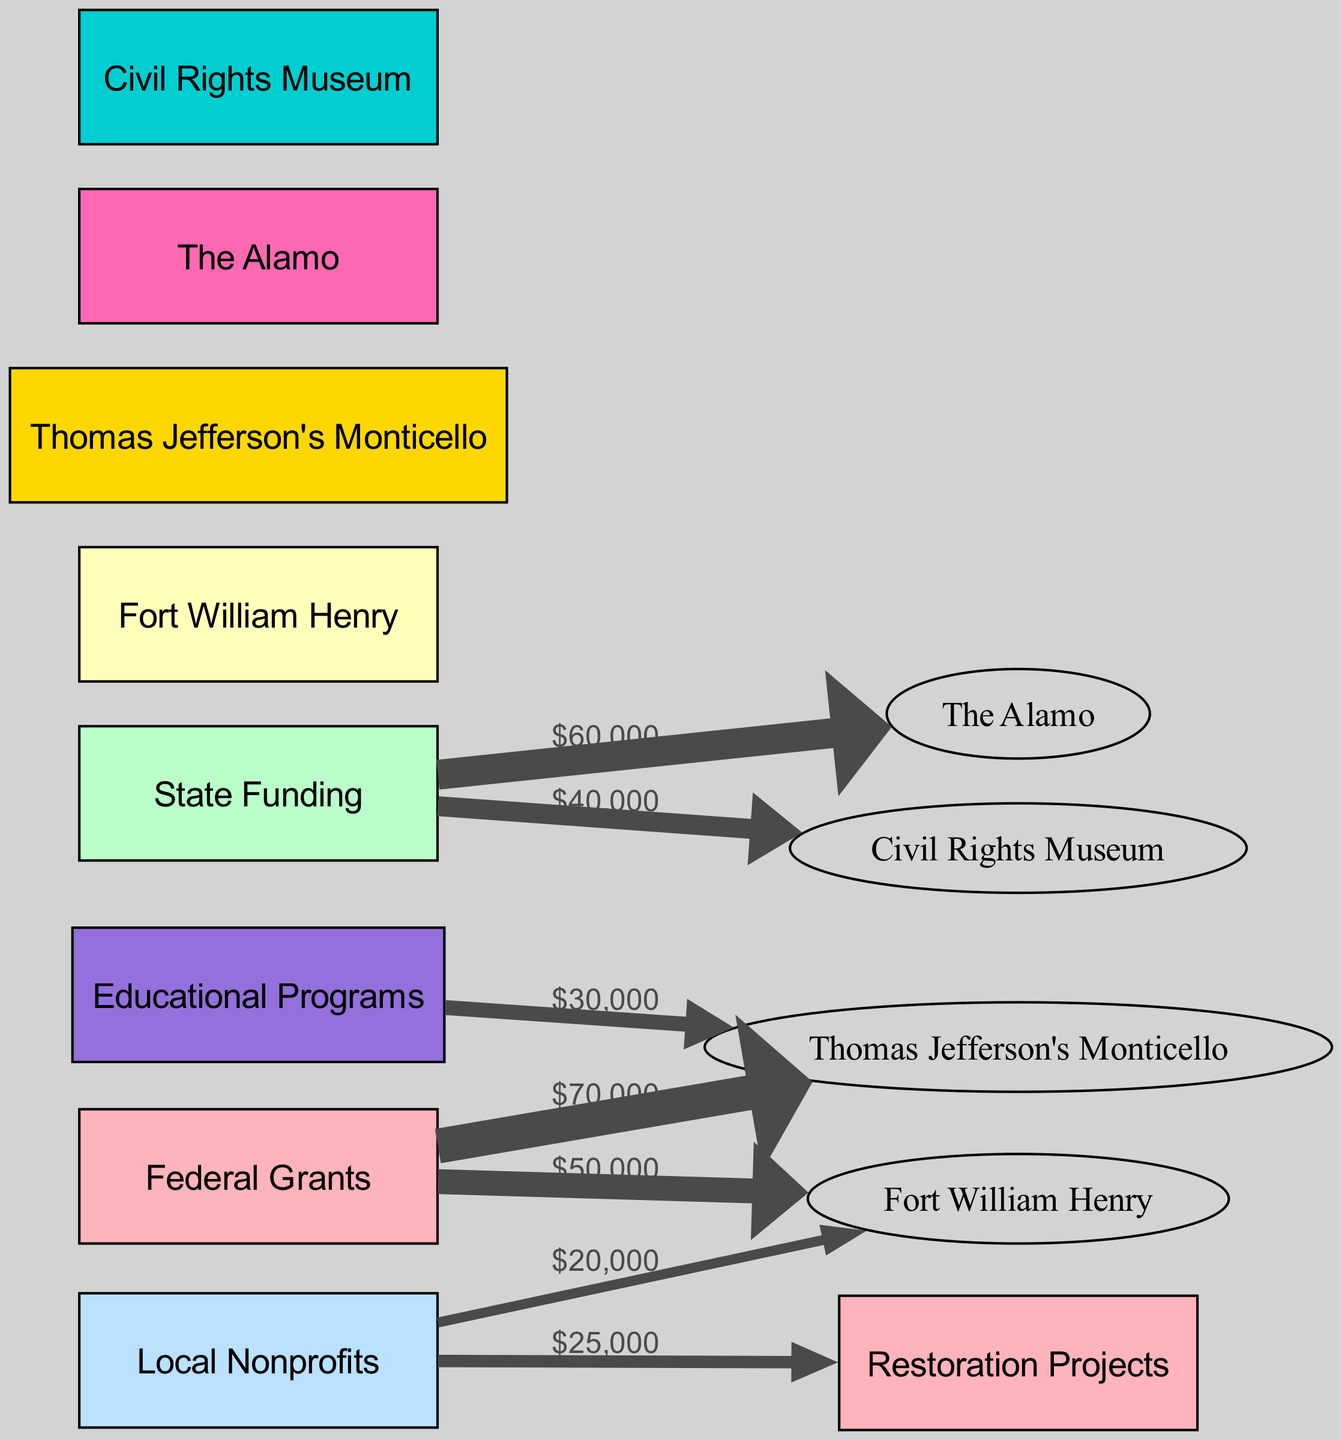What is the total funding allocated to Fort William Henry? To find the total funding for Fort William Henry, I will add the amounts from both Federal Grants and Local Nonprofits. Federal Grants provide $50,000 and Local Nonprofits provide $20,000. So, the total is $50,000 + $20,000 = $70,000.
Answer: $70,000 Which historical site received the highest funding from Federal Grants? The historical sites that received Federal Grants are Fort William Henry and Thomas Jefferson's Monticello, with grants of $50,000 and $70,000 respectively. The higher amount is $70,000 for Thomas Jefferson's Monticello.
Answer: Thomas Jefferson's Monticello What is the total amount of State Funding allocated to historical sites? The historical sites funded by State Funding are The Alamo and the Civil Rights Museum, which received $60,000 and $40,000, respectively. Adding these amounts gives $60,000 + $40,000 = $100,000 for State Funding.
Answer: $100,000 How much funding was allocated to Restoration Projects? From the diagram, the Restoration Projects received $25,000 from Local Nonprofits, and there are no other funding sources indicated for this category. Therefore, the total allocation is $25,000.
Answer: $25,000 Which source contributed the least amount of funding? The sources of funding are Federal Grants, State Funding, and Local Nonprofits. Reviewing the allocations: Federal Grants has $50,000 and $70,000, State Funding has $60,000 and $40,000, while Local Nonprofits has $20,000. The least is $20,000 from Local Nonprofits.
Answer: Local Nonprofits What is the combined funding for Thomas Jefferson's Monticello? Thomas Jefferson's Monticello received $70,000 from Federal Grants and $30,000 from Educational Programs. Adding these two amounts gives $70,000 + $30,000 = $100,000.
Answer: $100,000 How many nodes are represented in the diagram? Counting all the unique nodes in the diagram, there are 9 nodes identified: Federal Grants, State Funding, Local Nonprofits, Fort William Henry, Thomas Jefferson's Monticello, The Alamo, Civil Rights Museum, Educational Programs, and Restoration Projects. Therefore, the total number of nodes is 9.
Answer: 9 What is the relationship between Local Nonprofits and Restoration Projects? The relationship between Local Nonprofits and Restoration Projects is represented by a single link showing that Local Nonprofits contributed $25,000 to Restoration Projects.
Answer: $25,000 Which historical site has the least total funding? Comparing the total funding for each historical site, Fort William Henry has $70,000, Thomas Jefferson's Monticello has $100,000, The Alamo has $60,000, and the Civil Rights Museum has $40,000. The least amount of funding is $40,000 for the Civil Rights Museum.
Answer: Civil Rights Museum 